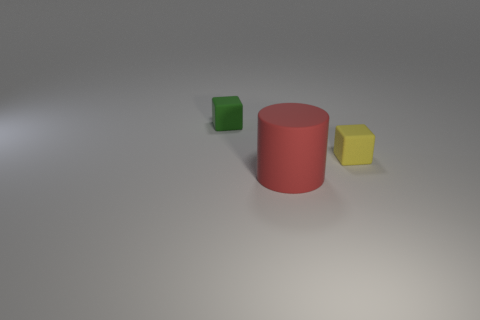Add 1 tiny brown cylinders. How many objects exist? 4 Subtract all cylinders. How many objects are left? 2 Subtract all tiny yellow matte objects. Subtract all small yellow rubber things. How many objects are left? 1 Add 3 large rubber cylinders. How many large rubber cylinders are left? 4 Add 1 cylinders. How many cylinders exist? 2 Subtract 1 red cylinders. How many objects are left? 2 Subtract all cyan cylinders. Subtract all red spheres. How many cylinders are left? 1 Subtract all cyan balls. How many gray cubes are left? 0 